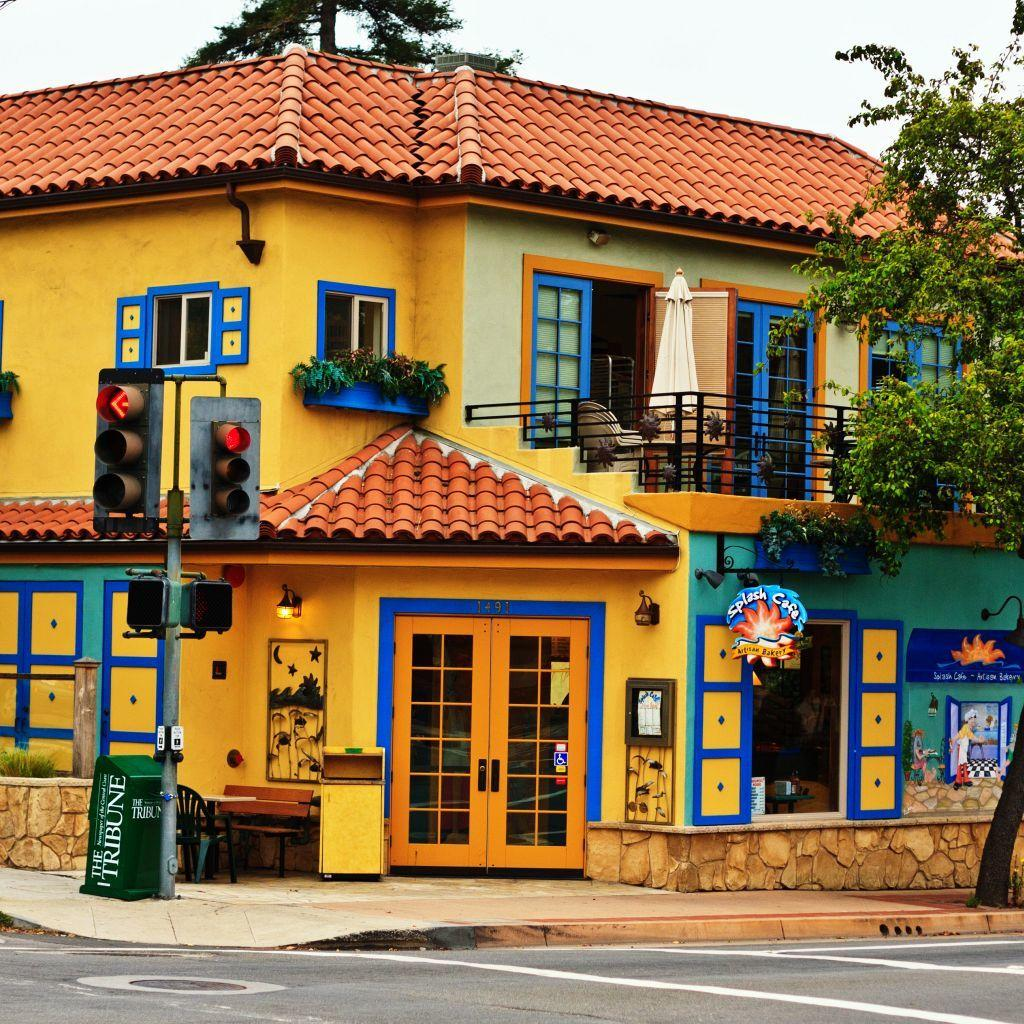What is in the foreground of the image? There is a road in the foreground of the image. What can be seen in the background of the image? There is a building, a door, a traffic signal pole, an umbrella, chairs, plants, trees, and a railing in the background of the image. What is visible in the sky in the background of the image? The sky is visible in the background of the image. What card is being played in the image? There is no card game or any cards present in the image. What word is being spelled out by the trees in the image? The trees in the image are not spelling out any words; they are simply trees. 